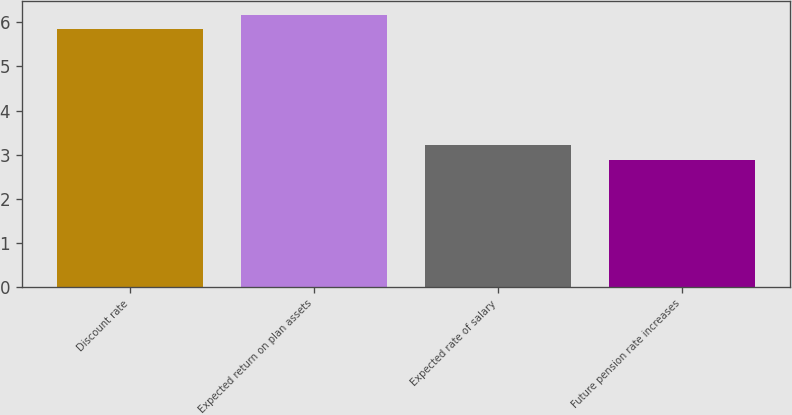<chart> <loc_0><loc_0><loc_500><loc_500><bar_chart><fcel>Discount rate<fcel>Expected return on plan assets<fcel>Expected rate of salary<fcel>Future pension rate increases<nl><fcel>5.84<fcel>6.17<fcel>3.21<fcel>2.88<nl></chart> 